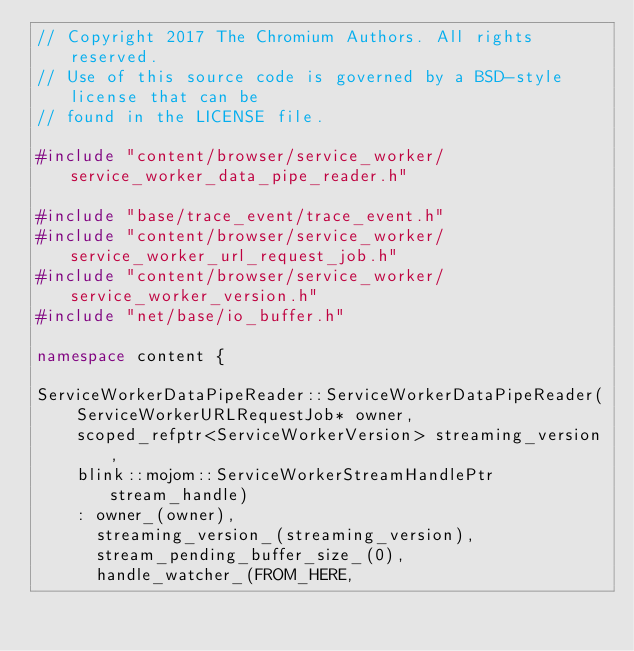<code> <loc_0><loc_0><loc_500><loc_500><_C++_>// Copyright 2017 The Chromium Authors. All rights reserved.
// Use of this source code is governed by a BSD-style license that can be
// found in the LICENSE file.

#include "content/browser/service_worker/service_worker_data_pipe_reader.h"

#include "base/trace_event/trace_event.h"
#include "content/browser/service_worker/service_worker_url_request_job.h"
#include "content/browser/service_worker/service_worker_version.h"
#include "net/base/io_buffer.h"

namespace content {

ServiceWorkerDataPipeReader::ServiceWorkerDataPipeReader(
    ServiceWorkerURLRequestJob* owner,
    scoped_refptr<ServiceWorkerVersion> streaming_version,
    blink::mojom::ServiceWorkerStreamHandlePtr stream_handle)
    : owner_(owner),
      streaming_version_(streaming_version),
      stream_pending_buffer_size_(0),
      handle_watcher_(FROM_HERE,</code> 